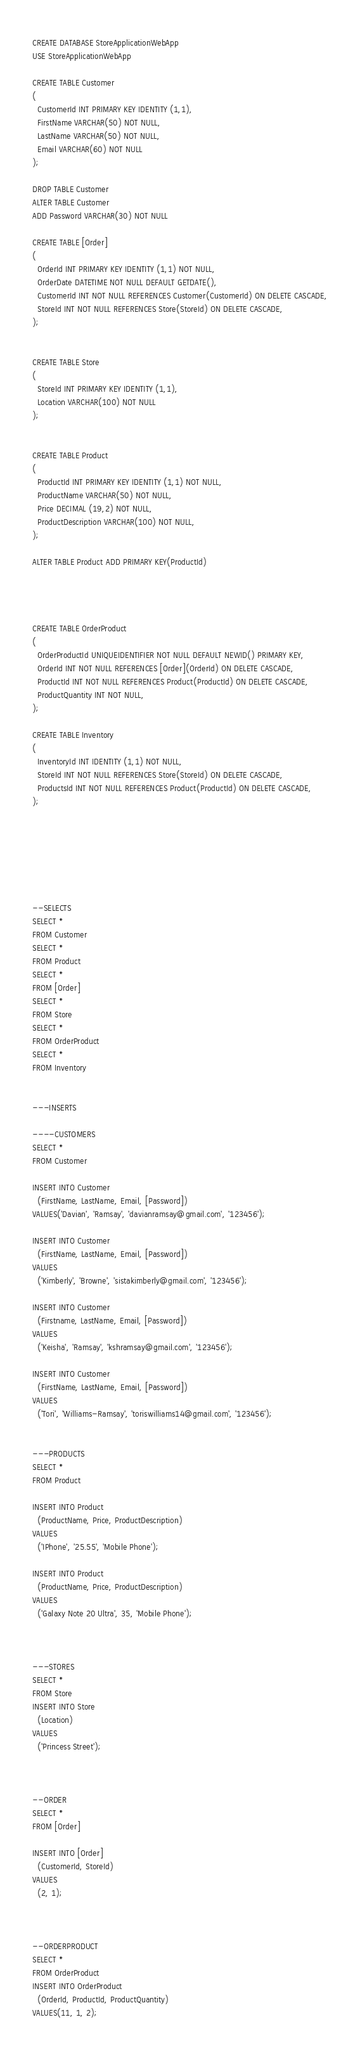<code> <loc_0><loc_0><loc_500><loc_500><_SQL_>CREATE DATABASE StoreApplicationWebApp
USE StoreApplicationWebApp

CREATE TABLE Customer
(
  CustomerId INT PRIMARY KEY IDENTITY (1,1),
  FirstName VARCHAR(50) NOT NULL,
  LastName VARCHAR(50) NOT NULL,
  Email VARCHAR(60) NOT NULL
);

DROP TABLE Customer
ALTER TABLE Customer
ADD Password VARCHAR(30) NOT NULL

CREATE TABLE [Order]
(
  OrderId INT PRIMARY KEY IDENTITY (1,1) NOT NULL,
  OrderDate DATETIME NOT NULL DEFAULT GETDATE(),
  CustomerId INT NOT NULL REFERENCES Customer(CustomerId) ON DELETE CASCADE,
  StoreId INT NOT NULL REFERENCES Store(StoreId) ON DELETE CASCADE,
);


CREATE TABLE Store
(
  StoreId INT PRIMARY KEY IDENTITY (1,1),
  Location VARCHAR(100) NOT NULL
);


CREATE TABLE Product
(
  ProductId INT PRIMARY KEY IDENTITY (1,1) NOT NULL,
  ProductName VARCHAR(50) NOT NULL,
  Price DECIMAL (19,2) NOT NULL,
  ProductDescription VARCHAR(100) NOT NULL,
);

ALTER TABLE Product ADD PRIMARY KEY(ProductId)




CREATE TABLE OrderProduct
(
  OrderProductId UNIQUEIDENTIFIER NOT NULL DEFAULT NEWID() PRIMARY KEY,
  OrderId INT NOT NULL REFERENCES [Order](OrderId) ON DELETE CASCADE,
  ProductId INT NOT NULL REFERENCES Product(ProductId) ON DELETE CASCADE,
  ProductQuantity INT NOT NULL,
);

CREATE TABLE Inventory
(
  InventoryId INT IDENTITY (1,1) NOT NULL,
  StoreId INT NOT NULL REFERENCES Store(StoreId) ON DELETE CASCADE,
  ProductsId INT NOT NULL REFERENCES Product(ProductId) ON DELETE CASCADE,
);







--SELECTS
SELECT *
FROM Customer
SELECT *
FROM Product
SELECT *
FROM [Order]
SELECT *
FROM Store
SELECT *
FROM OrderProduct
SELECT *
FROM Inventory


---INSERTS 

----CUSTOMERS 
SELECT *
FROM Customer

INSERT INTO Customer
  (FirstName, LastName, Email, [Password])
VALUES('Davian', 'Ramsay', 'davianramsay@gmail.com', '123456');

INSERT INTO Customer
  (FirstName, LastName, Email, [Password])
VALUES
  ('Kimberly', 'Browne', 'sistakimberly@gmail.com', '123456');

INSERT INTO Customer
  (Firstname, LastName, Email, [Password])
VALUES
  ('Keisha', 'Ramsay', 'kshramsay@gmail.com', '123456');

INSERT INTO Customer
  (FirstName, LastName, Email, [Password])
VALUES
  ('Tori', 'Williams-Ramsay', 'toriswilliams14@gmail.com', '123456');


---PRODUCTS 
SELECT *
FROM Product

INSERT INTO Product
  (ProductName, Price, ProductDescription)
VALUES
  ('IPhone', '25.55', 'Mobile Phone');

INSERT INTO Product
  (ProductName, Price, ProductDescription)
VALUES
  ('Galaxy Note 20 Ultra', 35, 'Mobile Phone');



---STORES
SELECT *
FROM Store
INSERT INTO Store
  (Location)
VALUES
  ('Princess Street');



--ORDER
SELECT *
FROM [Order]

INSERT INTO [Order]
  (CustomerId, StoreId)
VALUES
  (2, 1);



--ORDERPRODUCT
SELECT *
FROM OrderProduct
INSERT INTO OrderProduct
  (OrderId, ProductId, ProductQuantity)
VALUES(11, 1, 2);</code> 